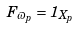<formula> <loc_0><loc_0><loc_500><loc_500>F _ { \varpi _ { p } } = 1 _ { X _ { p } }</formula> 